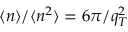<formula> <loc_0><loc_0><loc_500><loc_500>\langle n \rangle / \langle n ^ { 2 } \rangle = 6 \pi / q _ { T } ^ { 2 }</formula> 